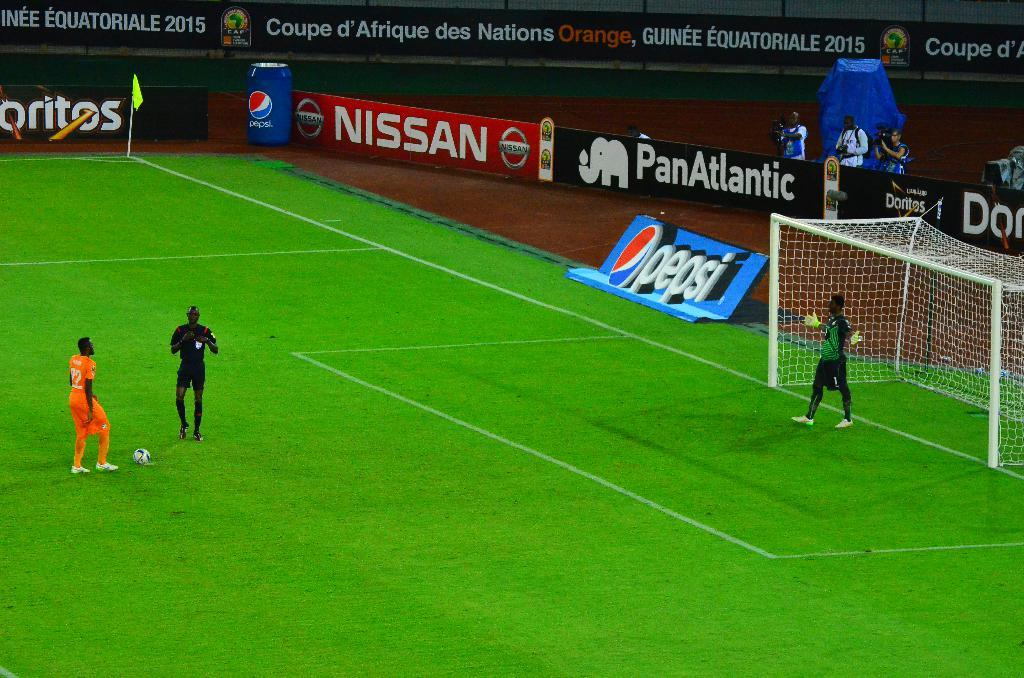<image>
Give a short and clear explanation of the subsequent image. three players on a soccer field and sponsor banners for doritos, nissan, pepsi, and panatlantic 